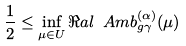Convert formula to latex. <formula><loc_0><loc_0><loc_500><loc_500>\frac { 1 } { 2 } \leq \inf _ { \mu \in U } \Re a l { \ A m b _ { g \gamma } ^ { ( \alpha ) } ( \mu ) }</formula> 